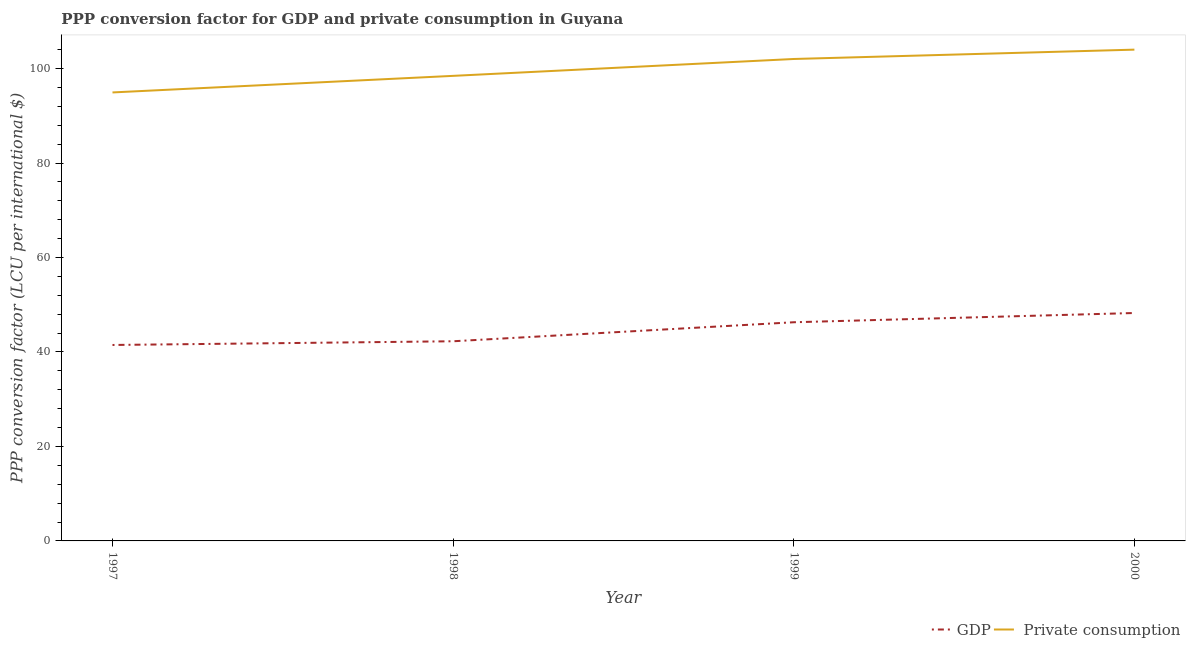Does the line corresponding to ppp conversion factor for private consumption intersect with the line corresponding to ppp conversion factor for gdp?
Your answer should be very brief. No. What is the ppp conversion factor for gdp in 2000?
Give a very brief answer. 48.25. Across all years, what is the maximum ppp conversion factor for private consumption?
Make the answer very short. 104.01. Across all years, what is the minimum ppp conversion factor for private consumption?
Keep it short and to the point. 94.95. In which year was the ppp conversion factor for gdp maximum?
Make the answer very short. 2000. In which year was the ppp conversion factor for gdp minimum?
Give a very brief answer. 1997. What is the total ppp conversion factor for gdp in the graph?
Ensure brevity in your answer.  178.3. What is the difference between the ppp conversion factor for gdp in 1997 and that in 2000?
Make the answer very short. -6.77. What is the difference between the ppp conversion factor for private consumption in 1999 and the ppp conversion factor for gdp in 2000?
Keep it short and to the point. 53.78. What is the average ppp conversion factor for gdp per year?
Provide a short and direct response. 44.57. In the year 1998, what is the difference between the ppp conversion factor for gdp and ppp conversion factor for private consumption?
Offer a very short reply. -56.19. In how many years, is the ppp conversion factor for private consumption greater than 72 LCU?
Your response must be concise. 4. What is the ratio of the ppp conversion factor for private consumption in 1998 to that in 1999?
Your response must be concise. 0.96. Is the ppp conversion factor for gdp in 1998 less than that in 1999?
Offer a terse response. Yes. Is the difference between the ppp conversion factor for private consumption in 1998 and 2000 greater than the difference between the ppp conversion factor for gdp in 1998 and 2000?
Provide a succinct answer. Yes. What is the difference between the highest and the second highest ppp conversion factor for private consumption?
Keep it short and to the point. 1.98. What is the difference between the highest and the lowest ppp conversion factor for gdp?
Give a very brief answer. 6.77. Does the ppp conversion factor for private consumption monotonically increase over the years?
Ensure brevity in your answer.  Yes. Is the ppp conversion factor for private consumption strictly greater than the ppp conversion factor for gdp over the years?
Provide a succinct answer. Yes. How many lines are there?
Make the answer very short. 2. Does the graph contain any zero values?
Your answer should be compact. No. Does the graph contain grids?
Provide a short and direct response. No. How many legend labels are there?
Provide a short and direct response. 2. How are the legend labels stacked?
Your answer should be compact. Horizontal. What is the title of the graph?
Your answer should be compact. PPP conversion factor for GDP and private consumption in Guyana. What is the label or title of the Y-axis?
Provide a short and direct response. PPP conversion factor (LCU per international $). What is the PPP conversion factor (LCU per international $) of GDP in 1997?
Offer a very short reply. 41.48. What is the PPP conversion factor (LCU per international $) in  Private consumption in 1997?
Provide a short and direct response. 94.95. What is the PPP conversion factor (LCU per international $) in GDP in 1998?
Make the answer very short. 42.27. What is the PPP conversion factor (LCU per international $) of  Private consumption in 1998?
Your answer should be compact. 98.46. What is the PPP conversion factor (LCU per international $) in GDP in 1999?
Your response must be concise. 46.29. What is the PPP conversion factor (LCU per international $) in  Private consumption in 1999?
Make the answer very short. 102.03. What is the PPP conversion factor (LCU per international $) in GDP in 2000?
Your answer should be very brief. 48.25. What is the PPP conversion factor (LCU per international $) of  Private consumption in 2000?
Give a very brief answer. 104.01. Across all years, what is the maximum PPP conversion factor (LCU per international $) of GDP?
Ensure brevity in your answer.  48.25. Across all years, what is the maximum PPP conversion factor (LCU per international $) of  Private consumption?
Offer a terse response. 104.01. Across all years, what is the minimum PPP conversion factor (LCU per international $) in GDP?
Make the answer very short. 41.48. Across all years, what is the minimum PPP conversion factor (LCU per international $) of  Private consumption?
Your answer should be very brief. 94.95. What is the total PPP conversion factor (LCU per international $) in GDP in the graph?
Your answer should be compact. 178.3. What is the total PPP conversion factor (LCU per international $) of  Private consumption in the graph?
Keep it short and to the point. 399.44. What is the difference between the PPP conversion factor (LCU per international $) in GDP in 1997 and that in 1998?
Provide a short and direct response. -0.79. What is the difference between the PPP conversion factor (LCU per international $) of  Private consumption in 1997 and that in 1998?
Your response must be concise. -3.51. What is the difference between the PPP conversion factor (LCU per international $) of GDP in 1997 and that in 1999?
Give a very brief answer. -4.81. What is the difference between the PPP conversion factor (LCU per international $) of  Private consumption in 1997 and that in 1999?
Your answer should be very brief. -7.08. What is the difference between the PPP conversion factor (LCU per international $) in GDP in 1997 and that in 2000?
Keep it short and to the point. -6.77. What is the difference between the PPP conversion factor (LCU per international $) in  Private consumption in 1997 and that in 2000?
Your response must be concise. -9.06. What is the difference between the PPP conversion factor (LCU per international $) in GDP in 1998 and that in 1999?
Your response must be concise. -4.03. What is the difference between the PPP conversion factor (LCU per international $) in  Private consumption in 1998 and that in 1999?
Provide a short and direct response. -3.57. What is the difference between the PPP conversion factor (LCU per international $) of GDP in 1998 and that in 2000?
Give a very brief answer. -5.98. What is the difference between the PPP conversion factor (LCU per international $) of  Private consumption in 1998 and that in 2000?
Your response must be concise. -5.55. What is the difference between the PPP conversion factor (LCU per international $) of GDP in 1999 and that in 2000?
Make the answer very short. -1.96. What is the difference between the PPP conversion factor (LCU per international $) of  Private consumption in 1999 and that in 2000?
Provide a succinct answer. -1.98. What is the difference between the PPP conversion factor (LCU per international $) of GDP in 1997 and the PPP conversion factor (LCU per international $) of  Private consumption in 1998?
Provide a short and direct response. -56.97. What is the difference between the PPP conversion factor (LCU per international $) in GDP in 1997 and the PPP conversion factor (LCU per international $) in  Private consumption in 1999?
Offer a very short reply. -60.55. What is the difference between the PPP conversion factor (LCU per international $) in GDP in 1997 and the PPP conversion factor (LCU per international $) in  Private consumption in 2000?
Your answer should be compact. -62.52. What is the difference between the PPP conversion factor (LCU per international $) in GDP in 1998 and the PPP conversion factor (LCU per international $) in  Private consumption in 1999?
Give a very brief answer. -59.76. What is the difference between the PPP conversion factor (LCU per international $) of GDP in 1998 and the PPP conversion factor (LCU per international $) of  Private consumption in 2000?
Make the answer very short. -61.74. What is the difference between the PPP conversion factor (LCU per international $) in GDP in 1999 and the PPP conversion factor (LCU per international $) in  Private consumption in 2000?
Your answer should be compact. -57.71. What is the average PPP conversion factor (LCU per international $) in GDP per year?
Ensure brevity in your answer.  44.57. What is the average PPP conversion factor (LCU per international $) of  Private consumption per year?
Provide a succinct answer. 99.86. In the year 1997, what is the difference between the PPP conversion factor (LCU per international $) in GDP and PPP conversion factor (LCU per international $) in  Private consumption?
Make the answer very short. -53.46. In the year 1998, what is the difference between the PPP conversion factor (LCU per international $) of GDP and PPP conversion factor (LCU per international $) of  Private consumption?
Give a very brief answer. -56.19. In the year 1999, what is the difference between the PPP conversion factor (LCU per international $) of GDP and PPP conversion factor (LCU per international $) of  Private consumption?
Ensure brevity in your answer.  -55.73. In the year 2000, what is the difference between the PPP conversion factor (LCU per international $) of GDP and PPP conversion factor (LCU per international $) of  Private consumption?
Your answer should be compact. -55.76. What is the ratio of the PPP conversion factor (LCU per international $) of GDP in 1997 to that in 1998?
Offer a terse response. 0.98. What is the ratio of the PPP conversion factor (LCU per international $) of  Private consumption in 1997 to that in 1998?
Keep it short and to the point. 0.96. What is the ratio of the PPP conversion factor (LCU per international $) in GDP in 1997 to that in 1999?
Your response must be concise. 0.9. What is the ratio of the PPP conversion factor (LCU per international $) in  Private consumption in 1997 to that in 1999?
Offer a terse response. 0.93. What is the ratio of the PPP conversion factor (LCU per international $) in GDP in 1997 to that in 2000?
Your response must be concise. 0.86. What is the ratio of the PPP conversion factor (LCU per international $) of  Private consumption in 1997 to that in 2000?
Keep it short and to the point. 0.91. What is the ratio of the PPP conversion factor (LCU per international $) of GDP in 1998 to that in 1999?
Your response must be concise. 0.91. What is the ratio of the PPP conversion factor (LCU per international $) of GDP in 1998 to that in 2000?
Your answer should be very brief. 0.88. What is the ratio of the PPP conversion factor (LCU per international $) in  Private consumption in 1998 to that in 2000?
Provide a succinct answer. 0.95. What is the ratio of the PPP conversion factor (LCU per international $) of GDP in 1999 to that in 2000?
Make the answer very short. 0.96. What is the ratio of the PPP conversion factor (LCU per international $) in  Private consumption in 1999 to that in 2000?
Ensure brevity in your answer.  0.98. What is the difference between the highest and the second highest PPP conversion factor (LCU per international $) in GDP?
Ensure brevity in your answer.  1.96. What is the difference between the highest and the second highest PPP conversion factor (LCU per international $) in  Private consumption?
Ensure brevity in your answer.  1.98. What is the difference between the highest and the lowest PPP conversion factor (LCU per international $) in GDP?
Your response must be concise. 6.77. What is the difference between the highest and the lowest PPP conversion factor (LCU per international $) in  Private consumption?
Ensure brevity in your answer.  9.06. 